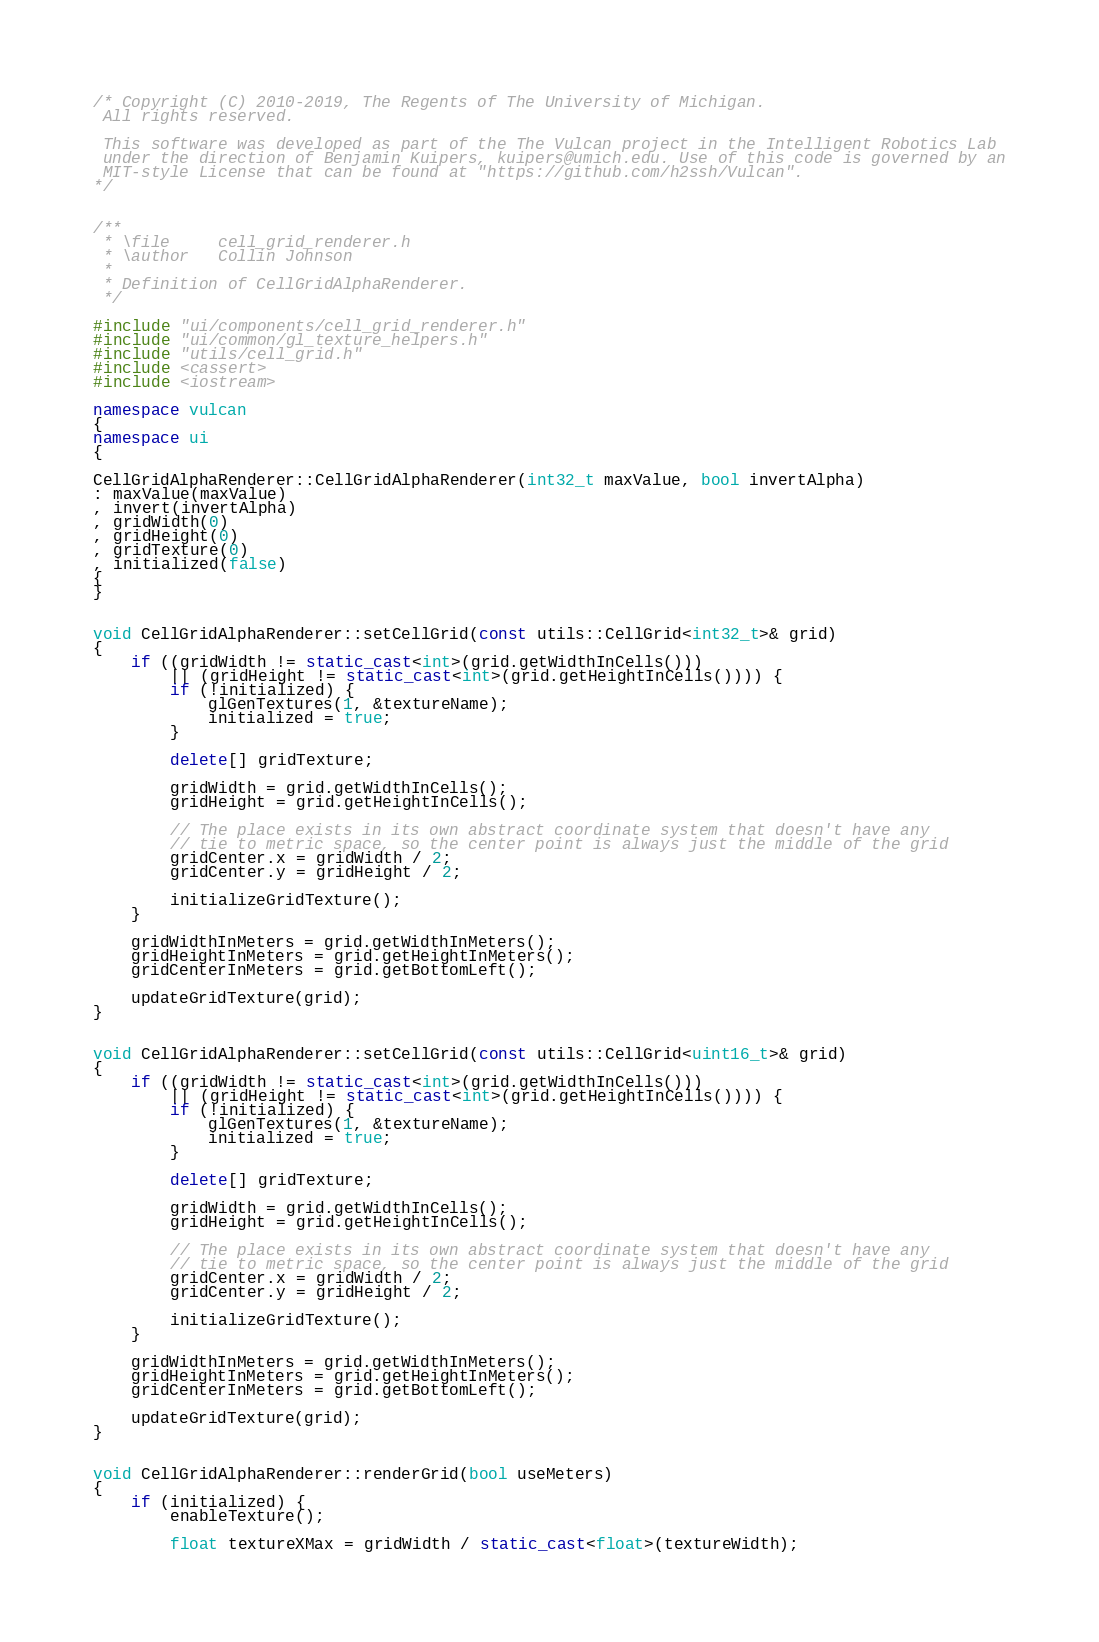Convert code to text. <code><loc_0><loc_0><loc_500><loc_500><_C++_>/* Copyright (C) 2010-2019, The Regents of The University of Michigan.
 All rights reserved.

 This software was developed as part of the The Vulcan project in the Intelligent Robotics Lab
 under the direction of Benjamin Kuipers, kuipers@umich.edu. Use of this code is governed by an
 MIT-style License that can be found at "https://github.com/h2ssh/Vulcan".
*/


/**
 * \file     cell_grid_renderer.h
 * \author   Collin Johnson
 *
 * Definition of CellGridAlphaRenderer.
 */

#include "ui/components/cell_grid_renderer.h"
#include "ui/common/gl_texture_helpers.h"
#include "utils/cell_grid.h"
#include <cassert>
#include <iostream>

namespace vulcan
{
namespace ui
{

CellGridAlphaRenderer::CellGridAlphaRenderer(int32_t maxValue, bool invertAlpha)
: maxValue(maxValue)
, invert(invertAlpha)
, gridWidth(0)
, gridHeight(0)
, gridTexture(0)
, initialized(false)
{
}


void CellGridAlphaRenderer::setCellGrid(const utils::CellGrid<int32_t>& grid)
{
    if ((gridWidth != static_cast<int>(grid.getWidthInCells()))
        || (gridHeight != static_cast<int>(grid.getHeightInCells()))) {
        if (!initialized) {
            glGenTextures(1, &textureName);
            initialized = true;
        }

        delete[] gridTexture;

        gridWidth = grid.getWidthInCells();
        gridHeight = grid.getHeightInCells();

        // The place exists in its own abstract coordinate system that doesn't have any
        // tie to metric space, so the center point is always just the middle of the grid
        gridCenter.x = gridWidth / 2;
        gridCenter.y = gridHeight / 2;

        initializeGridTexture();
    }

    gridWidthInMeters = grid.getWidthInMeters();
    gridHeightInMeters = grid.getHeightInMeters();
    gridCenterInMeters = grid.getBottomLeft();

    updateGridTexture(grid);
}


void CellGridAlphaRenderer::setCellGrid(const utils::CellGrid<uint16_t>& grid)
{
    if ((gridWidth != static_cast<int>(grid.getWidthInCells()))
        || (gridHeight != static_cast<int>(grid.getHeightInCells()))) {
        if (!initialized) {
            glGenTextures(1, &textureName);
            initialized = true;
        }

        delete[] gridTexture;

        gridWidth = grid.getWidthInCells();
        gridHeight = grid.getHeightInCells();

        // The place exists in its own abstract coordinate system that doesn't have any
        // tie to metric space, so the center point is always just the middle of the grid
        gridCenter.x = gridWidth / 2;
        gridCenter.y = gridHeight / 2;

        initializeGridTexture();
    }

    gridWidthInMeters = grid.getWidthInMeters();
    gridHeightInMeters = grid.getHeightInMeters();
    gridCenterInMeters = grid.getBottomLeft();

    updateGridTexture(grid);
}


void CellGridAlphaRenderer::renderGrid(bool useMeters)
{
    if (initialized) {
        enableTexture();

        float textureXMax = gridWidth / static_cast<float>(textureWidth);</code> 